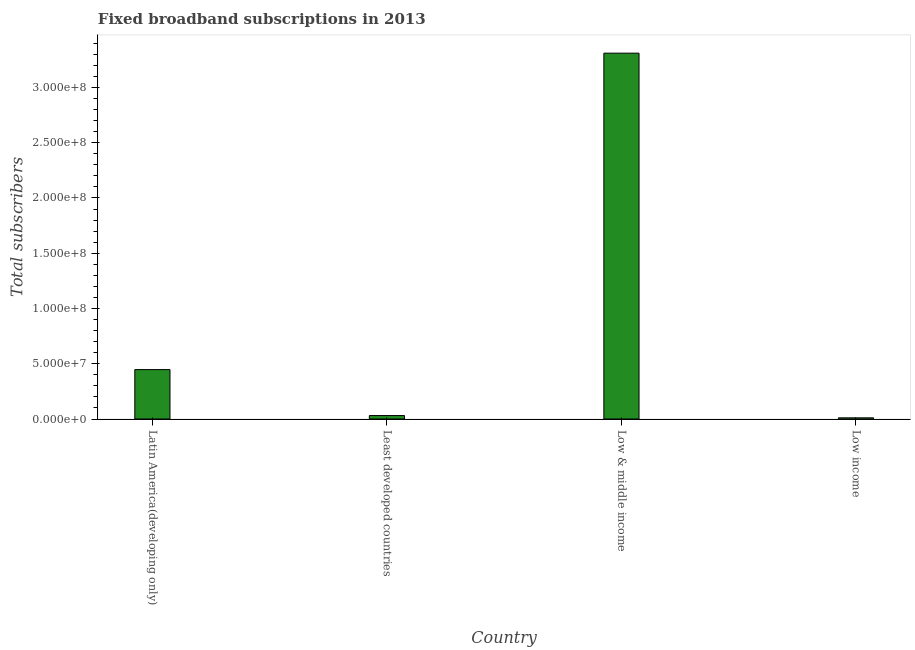Does the graph contain grids?
Your response must be concise. No. What is the title of the graph?
Make the answer very short. Fixed broadband subscriptions in 2013. What is the label or title of the Y-axis?
Make the answer very short. Total subscribers. What is the total number of fixed broadband subscriptions in Latin America(developing only)?
Give a very brief answer. 4.47e+07. Across all countries, what is the maximum total number of fixed broadband subscriptions?
Offer a terse response. 3.31e+08. Across all countries, what is the minimum total number of fixed broadband subscriptions?
Ensure brevity in your answer.  1.07e+06. In which country was the total number of fixed broadband subscriptions maximum?
Give a very brief answer. Low & middle income. In which country was the total number of fixed broadband subscriptions minimum?
Ensure brevity in your answer.  Low income. What is the sum of the total number of fixed broadband subscriptions?
Provide a succinct answer. 3.80e+08. What is the difference between the total number of fixed broadband subscriptions in Least developed countries and Low & middle income?
Give a very brief answer. -3.28e+08. What is the average total number of fixed broadband subscriptions per country?
Your response must be concise. 9.50e+07. What is the median total number of fixed broadband subscriptions?
Offer a very short reply. 2.39e+07. In how many countries, is the total number of fixed broadband subscriptions greater than 330000000 ?
Ensure brevity in your answer.  1. What is the ratio of the total number of fixed broadband subscriptions in Latin America(developing only) to that in Low income?
Your response must be concise. 41.78. Is the difference between the total number of fixed broadband subscriptions in Latin America(developing only) and Low income greater than the difference between any two countries?
Keep it short and to the point. No. What is the difference between the highest and the second highest total number of fixed broadband subscriptions?
Offer a terse response. 2.86e+08. Is the sum of the total number of fixed broadband subscriptions in Low & middle income and Low income greater than the maximum total number of fixed broadband subscriptions across all countries?
Make the answer very short. Yes. What is the difference between the highest and the lowest total number of fixed broadband subscriptions?
Ensure brevity in your answer.  3.30e+08. In how many countries, is the total number of fixed broadband subscriptions greater than the average total number of fixed broadband subscriptions taken over all countries?
Your answer should be compact. 1. How many bars are there?
Provide a short and direct response. 4. Are all the bars in the graph horizontal?
Keep it short and to the point. No. How many countries are there in the graph?
Keep it short and to the point. 4. Are the values on the major ticks of Y-axis written in scientific E-notation?
Ensure brevity in your answer.  Yes. What is the Total subscribers in Latin America(developing only)?
Your answer should be very brief. 4.47e+07. What is the Total subscribers in Least developed countries?
Keep it short and to the point. 3.13e+06. What is the Total subscribers in Low & middle income?
Your response must be concise. 3.31e+08. What is the Total subscribers in Low income?
Provide a succinct answer. 1.07e+06. What is the difference between the Total subscribers in Latin America(developing only) and Least developed countries?
Give a very brief answer. 4.16e+07. What is the difference between the Total subscribers in Latin America(developing only) and Low & middle income?
Keep it short and to the point. -2.86e+08. What is the difference between the Total subscribers in Latin America(developing only) and Low income?
Offer a terse response. 4.36e+07. What is the difference between the Total subscribers in Least developed countries and Low & middle income?
Provide a succinct answer. -3.28e+08. What is the difference between the Total subscribers in Least developed countries and Low income?
Your response must be concise. 2.06e+06. What is the difference between the Total subscribers in Low & middle income and Low income?
Make the answer very short. 3.30e+08. What is the ratio of the Total subscribers in Latin America(developing only) to that in Least developed countries?
Ensure brevity in your answer.  14.28. What is the ratio of the Total subscribers in Latin America(developing only) to that in Low & middle income?
Your answer should be compact. 0.14. What is the ratio of the Total subscribers in Latin America(developing only) to that in Low income?
Your response must be concise. 41.78. What is the ratio of the Total subscribers in Least developed countries to that in Low & middle income?
Your answer should be very brief. 0.01. What is the ratio of the Total subscribers in Least developed countries to that in Low income?
Your answer should be compact. 2.93. What is the ratio of the Total subscribers in Low & middle income to that in Low income?
Your response must be concise. 309.31. 